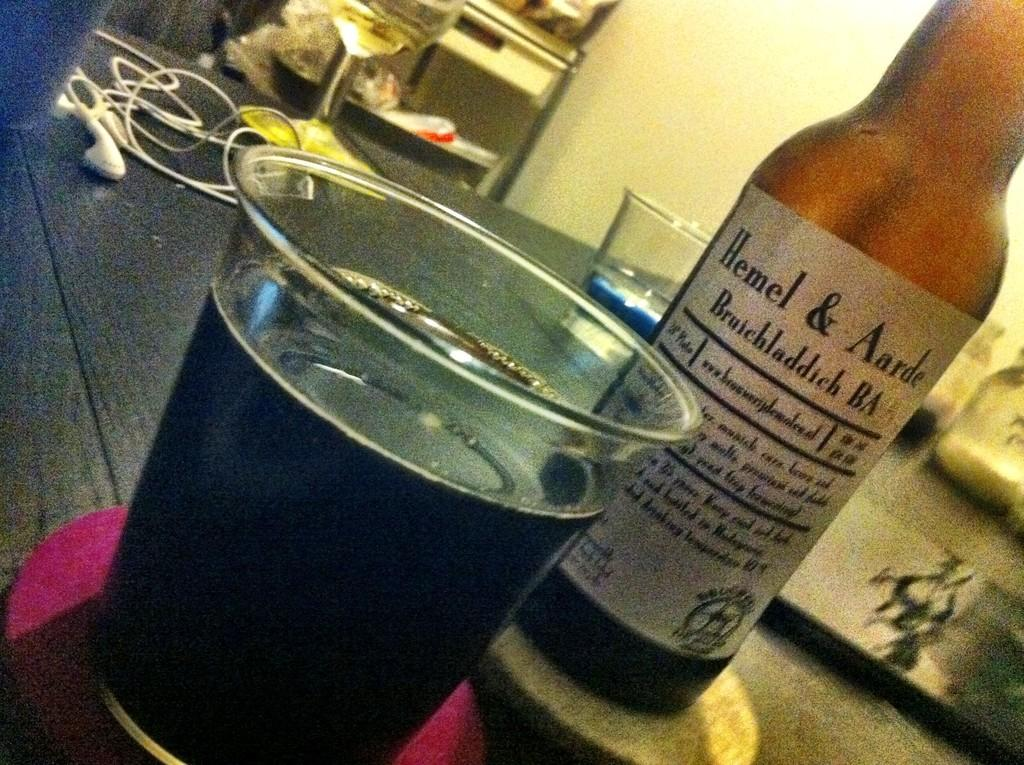<image>
Describe the image concisely. A bottle of Hemel & Andre Bruichladdich Ba next to a full glass. 